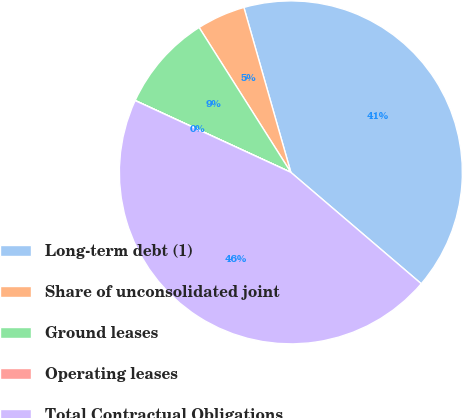<chart> <loc_0><loc_0><loc_500><loc_500><pie_chart><fcel>Long-term debt (1)<fcel>Share of unconsolidated joint<fcel>Ground leases<fcel>Operating leases<fcel>Total Contractual Obligations<nl><fcel>40.66%<fcel>4.57%<fcel>9.13%<fcel>0.01%<fcel>45.62%<nl></chart> 